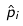Convert formula to latex. <formula><loc_0><loc_0><loc_500><loc_500>\hat { p } _ { i }</formula> 